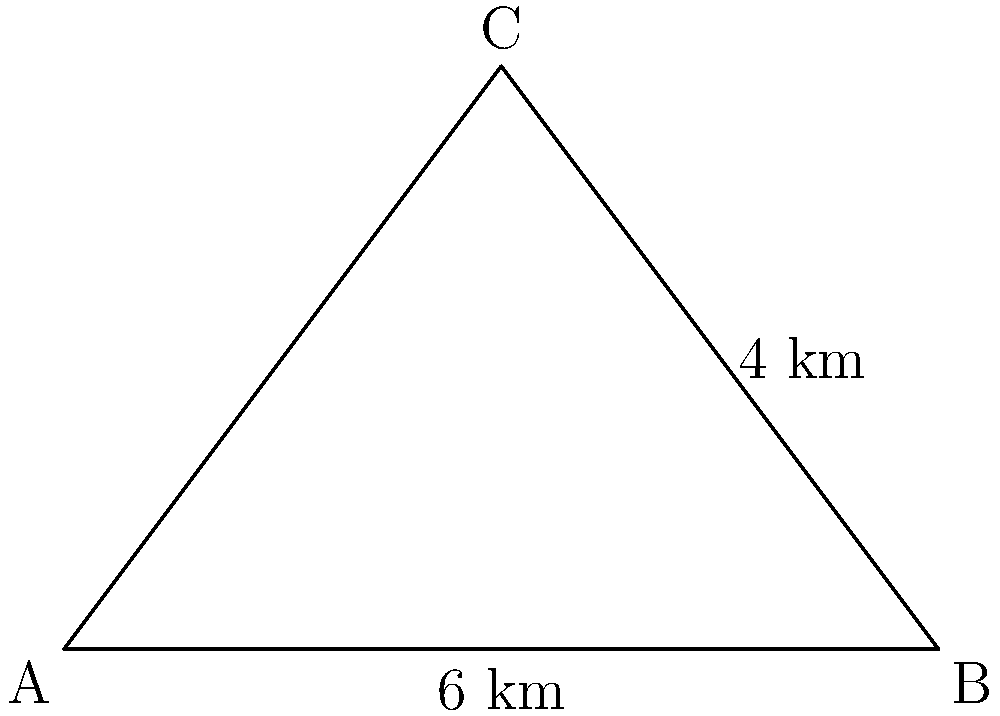In a moonlit forest, a triangular clearing is illuminated. The base of the clearing measures 6 km, and the perpendicular height from the base to the opposite vertex is 4 km. Calculate the area of this moonlit clearing, considering its importance for nocturnal wildlife activities. To find the area of the triangular clearing, we'll use the formula for the area of a triangle:

1. The formula for the area of a triangle is:
   $$A = \frac{1}{2} \times base \times height$$

2. We are given:
   - Base = 6 km
   - Height = 4 km

3. Let's substitute these values into the formula:
   $$A = \frac{1}{2} \times 6 \text{ km} \times 4 \text{ km}$$

4. Simplify:
   $$A = \frac{1}{2} \times 24 \text{ km}^2 = 12 \text{ km}^2$$

Thus, the area of the moonlit clearing is 12 square kilometers.

This large, naturally dark area is crucial for nocturnal wildlife, allowing them to carry out essential activities such as hunting, foraging, and mating without artificial light interference. It also helps maintain the natural circadian rhythms of both animals and plants in the ecosystem.
Answer: 12 km² 